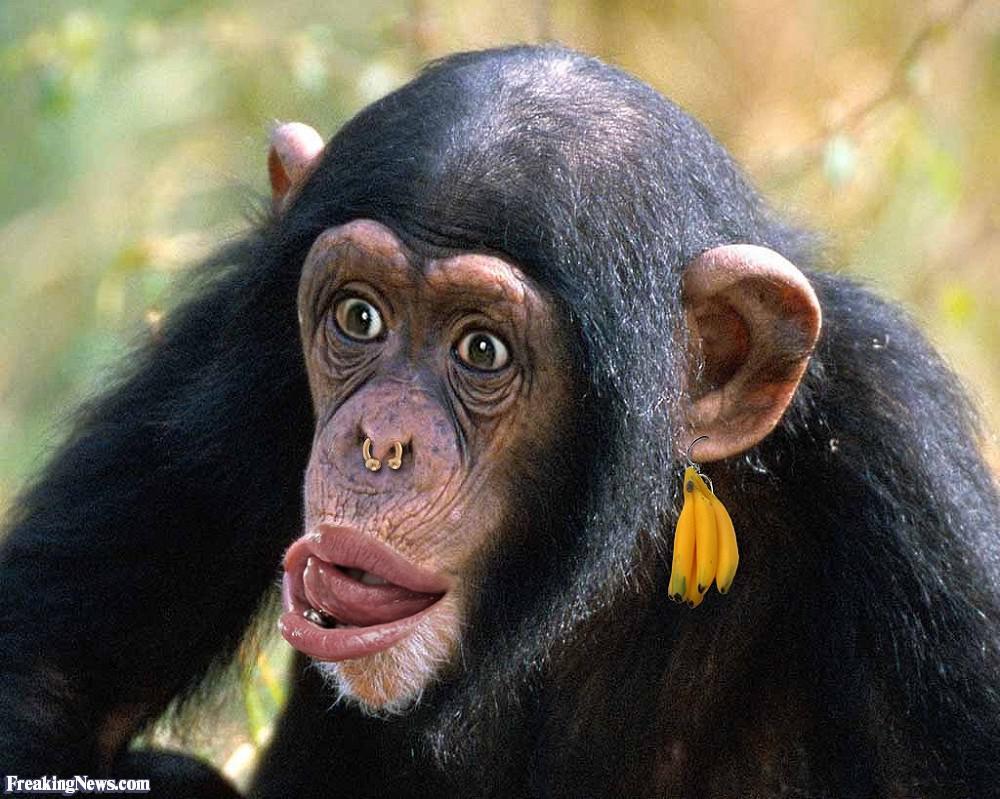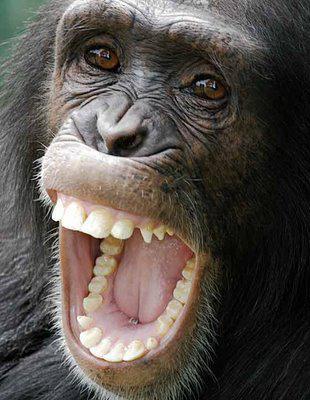The first image is the image on the left, the second image is the image on the right. Considering the images on both sides, is "One monkey is holding another in one of the images." valid? Answer yes or no. No. 